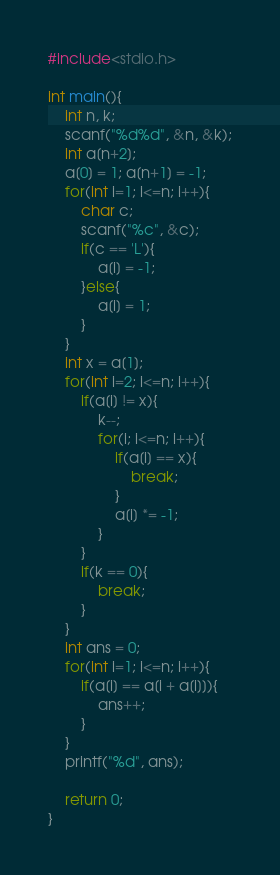Convert code to text. <code><loc_0><loc_0><loc_500><loc_500><_C_>#include<stdio.h>

int main(){
    int n, k;
    scanf("%d%d", &n, &k);
    int a[n+2];
    a[0] = 1; a[n+1] = -1;
    for(int i=1; i<=n; i++){
        char c;
        scanf("%c", &c);
        if(c == 'L'){
            a[i] = -1;
        }else{
            a[i] = 1;
        }
    }
    int x = a[1];
    for(int i=2; i<=n; i++){
        if(a[i] != x){
            k--;
            for(i; i<=n; i++){
                if(a[i] == x){
                    break;
                }
                a[i] *= -1;
            }
        }
        if(k == 0){
            break;
        }
    }
    int ans = 0;
    for(int i=1; i<=n; i++){
        if(a[i] == a[i + a[i]]){
            ans++;
        }
    }
    printf("%d", ans);

    return 0;
}</code> 